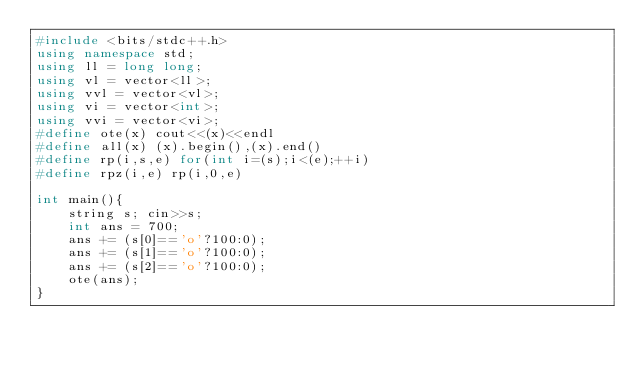Convert code to text. <code><loc_0><loc_0><loc_500><loc_500><_C++_>#include <bits/stdc++.h>
using namespace std;
using ll = long long;
using vl = vector<ll>;
using vvl = vector<vl>;
using vi = vector<int>;
using vvi = vector<vi>;
#define ote(x) cout<<(x)<<endl
#define all(x) (x).begin(),(x).end()
#define rp(i,s,e) for(int i=(s);i<(e);++i)
#define rpz(i,e) rp(i,0,e)

int main(){
	string s; cin>>s;
	int ans = 700;
	ans += (s[0]=='o'?100:0);
	ans += (s[1]=='o'?100:0);
	ans += (s[2]=='o'?100:0);
	ote(ans);
}
</code> 